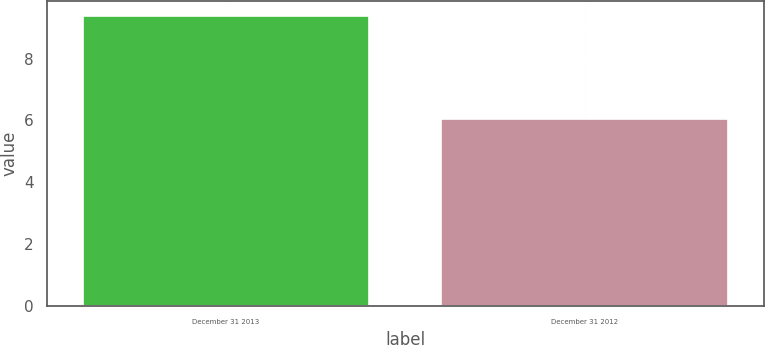<chart> <loc_0><loc_0><loc_500><loc_500><bar_chart><fcel>December 31 2013<fcel>December 31 2012<nl><fcel>9.39<fcel>6.04<nl></chart> 